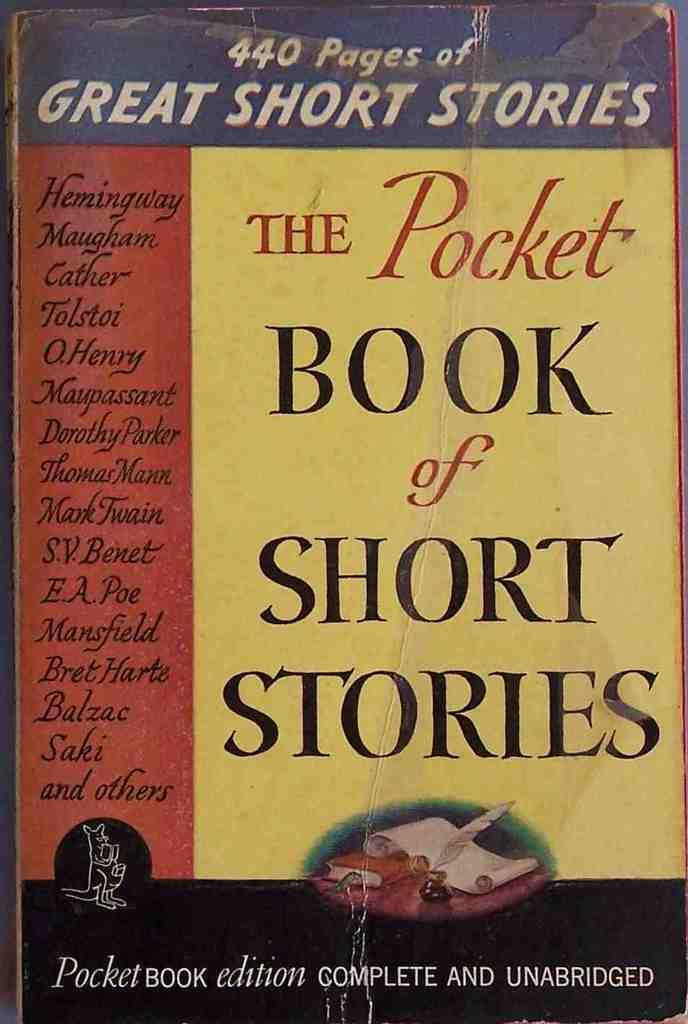<image>
Summarize the visual content of the image. A book of short stories has a yellow and red cover. 